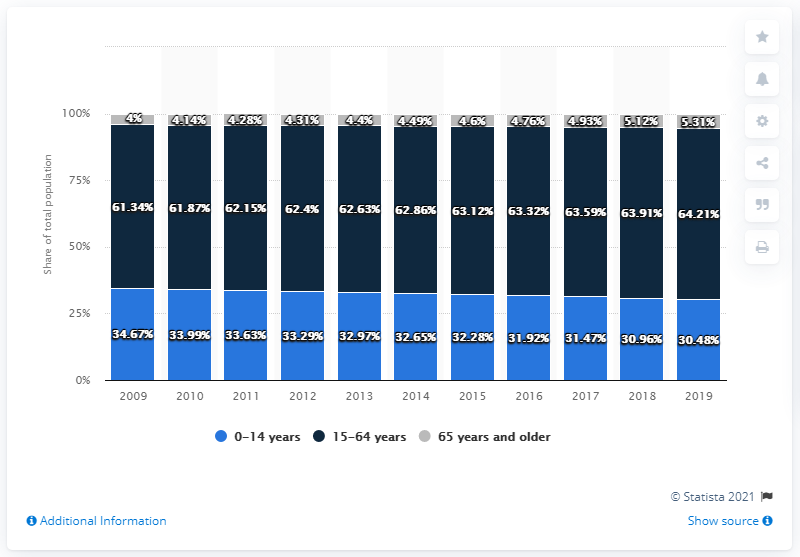List a handful of essential elements in this visual. The 15-64 year age group with the highest percentage in the total population is the 65 years and over group. The group of individuals between 0 and 14 years old had the highest percentage of the total population in 2009. 